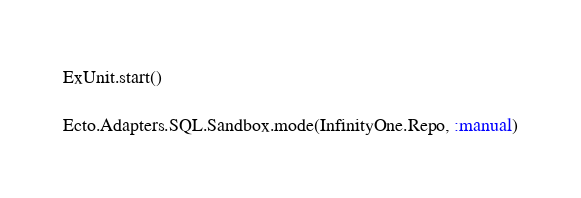Convert code to text. <code><loc_0><loc_0><loc_500><loc_500><_Elixir_>ExUnit.start()

Ecto.Adapters.SQL.Sandbox.mode(InfinityOne.Repo, :manual)
</code> 